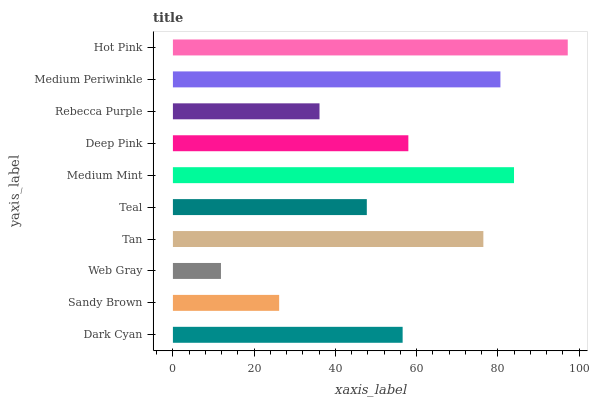Is Web Gray the minimum?
Answer yes or no. Yes. Is Hot Pink the maximum?
Answer yes or no. Yes. Is Sandy Brown the minimum?
Answer yes or no. No. Is Sandy Brown the maximum?
Answer yes or no. No. Is Dark Cyan greater than Sandy Brown?
Answer yes or no. Yes. Is Sandy Brown less than Dark Cyan?
Answer yes or no. Yes. Is Sandy Brown greater than Dark Cyan?
Answer yes or no. No. Is Dark Cyan less than Sandy Brown?
Answer yes or no. No. Is Deep Pink the high median?
Answer yes or no. Yes. Is Dark Cyan the low median?
Answer yes or no. Yes. Is Medium Periwinkle the high median?
Answer yes or no. No. Is Web Gray the low median?
Answer yes or no. No. 